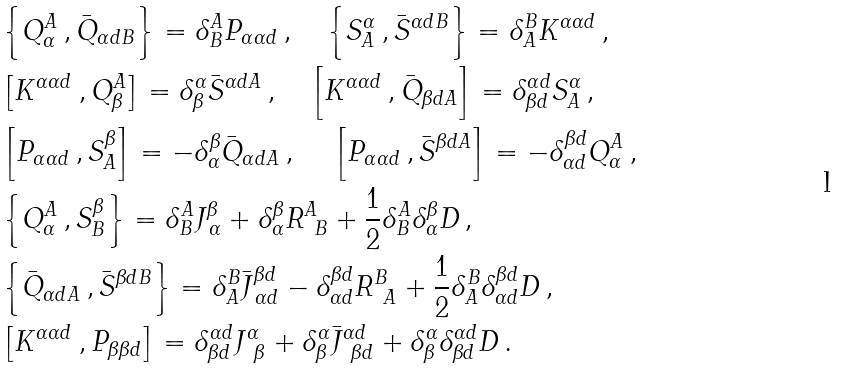<formula> <loc_0><loc_0><loc_500><loc_500>& \left \{ Q ^ { A } _ { \alpha } \, , \bar { Q } _ { \alpha d B } \right \} = \delta ^ { A } _ { B } P _ { \alpha \alpha d } \, , \quad \left \{ S ^ { \alpha } _ { A } \, , \bar { S } ^ { \alpha d B } \right \} = \delta ^ { B } _ { A } K ^ { \alpha \alpha d } \, , \\ & \left [ K ^ { \alpha \alpha d } \, , Q ^ { A } _ { \beta } \right ] = \delta ^ { \alpha } _ { \beta } \bar { S } ^ { \alpha d A } \, , \quad \left [ K ^ { \alpha \alpha d } \, , \bar { Q } _ { \beta d A } \right ] = \delta ^ { \alpha d } _ { \beta d } S ^ { \alpha } _ { A } \, , \\ & \left [ P _ { \alpha \alpha d } \, , S ^ { \beta } _ { A } \right ] = - \delta ^ { \beta } _ { \alpha } \bar { Q } _ { \alpha d A } \, , \quad \, \left [ P _ { \alpha \alpha d } \, , \bar { S } ^ { \beta d A } \right ] = - \delta ^ { \beta d } _ { \alpha d } Q _ { \alpha } ^ { A } \, , \\ & \left \{ Q ^ { A } _ { \alpha } \, , S ^ { \beta } _ { B } \right \} = \delta ^ { A } _ { B } J ^ { \beta } _ { \, \alpha } + \delta ^ { \beta } _ { \alpha } R ^ { A } _ { \ B } + \frac { 1 } { 2 } \delta ^ { A } _ { B } \delta ^ { \beta } _ { \alpha } D \, , \\ & \left \{ \bar { Q } _ { \alpha d A } \, , \bar { S } ^ { \beta d B } \right \} = \delta ^ { B } _ { A } \bar { J } ^ { \beta d } _ { \, \alpha d } - \delta ^ { \beta d } _ { \alpha d } R ^ { B } _ { \ A } + \frac { 1 } { 2 } \delta ^ { B } _ { A } \delta ^ { \beta d } _ { \alpha d } D \, , \\ & \left [ K ^ { \alpha \alpha d } \, , P _ { \beta \beta d } \right ] = \delta ^ { \alpha d } _ { \beta d } J ^ { \alpha } _ { \ \beta } + \delta ^ { \alpha } _ { \beta } \bar { J } ^ { \alpha d } _ { \ \beta d } + \delta ^ { \alpha } _ { \beta } \delta ^ { \alpha d } _ { \beta d } D \, .</formula> 